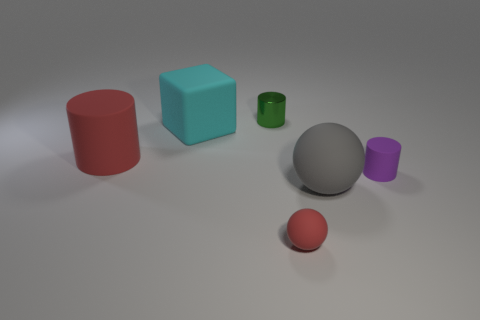Subtract all shiny cylinders. How many cylinders are left? 2 Subtract 1 cubes. How many cubes are left? 0 Subtract all blue cylinders. Subtract all red spheres. How many cylinders are left? 3 Subtract all blue cubes. How many red balls are left? 1 Subtract all large brown spheres. Subtract all tiny matte things. How many objects are left? 4 Add 6 purple rubber cylinders. How many purple rubber cylinders are left? 7 Add 5 large yellow metallic objects. How many large yellow metallic objects exist? 5 Add 4 large brown balls. How many objects exist? 10 Subtract all red cylinders. How many cylinders are left? 2 Subtract 1 cyan blocks. How many objects are left? 5 